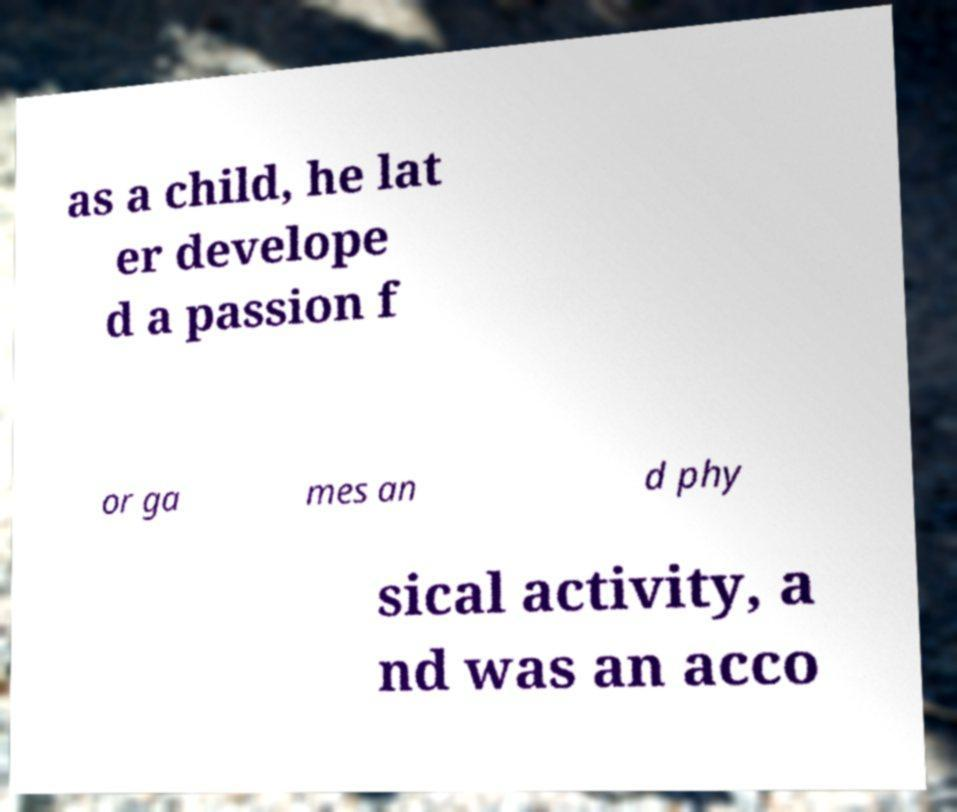Can you accurately transcribe the text from the provided image for me? as a child, he lat er develope d a passion f or ga mes an d phy sical activity, a nd was an acco 